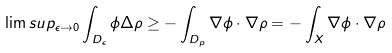<formula> <loc_0><loc_0><loc_500><loc_500>\lim s u p _ { \epsilon \rightarrow 0 } \int _ { D _ { \epsilon } } \phi \Delta \rho \geq - \int _ { D _ { p } } \nabla \phi \cdot \nabla \rho = - \int _ { X } \nabla \phi \cdot \nabla \rho</formula> 